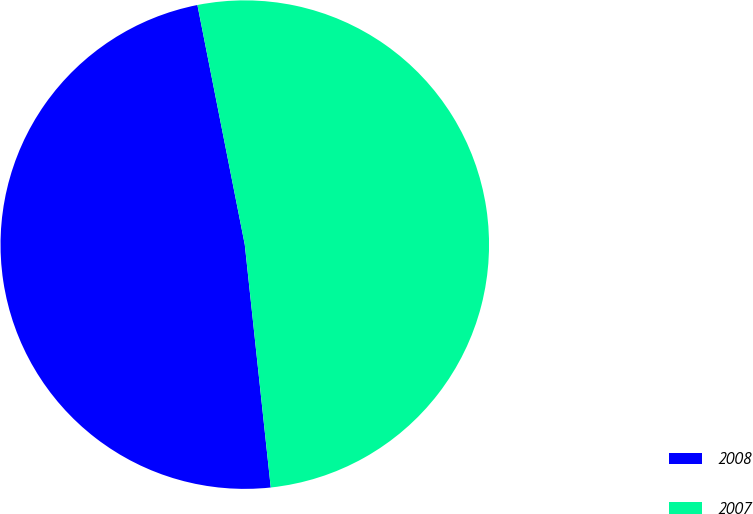Convert chart to OTSL. <chart><loc_0><loc_0><loc_500><loc_500><pie_chart><fcel>2008<fcel>2007<nl><fcel>48.59%<fcel>51.41%<nl></chart> 